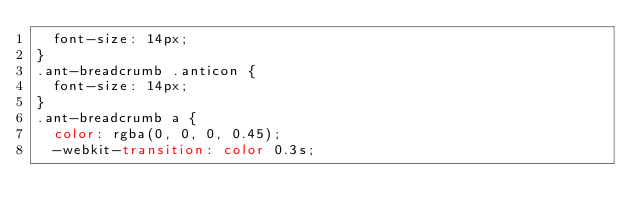Convert code to text. <code><loc_0><loc_0><loc_500><loc_500><_CSS_>  font-size: 14px;
}
.ant-breadcrumb .anticon {
  font-size: 14px;
}
.ant-breadcrumb a {
  color: rgba(0, 0, 0, 0.45);
  -webkit-transition: color 0.3s;</code> 